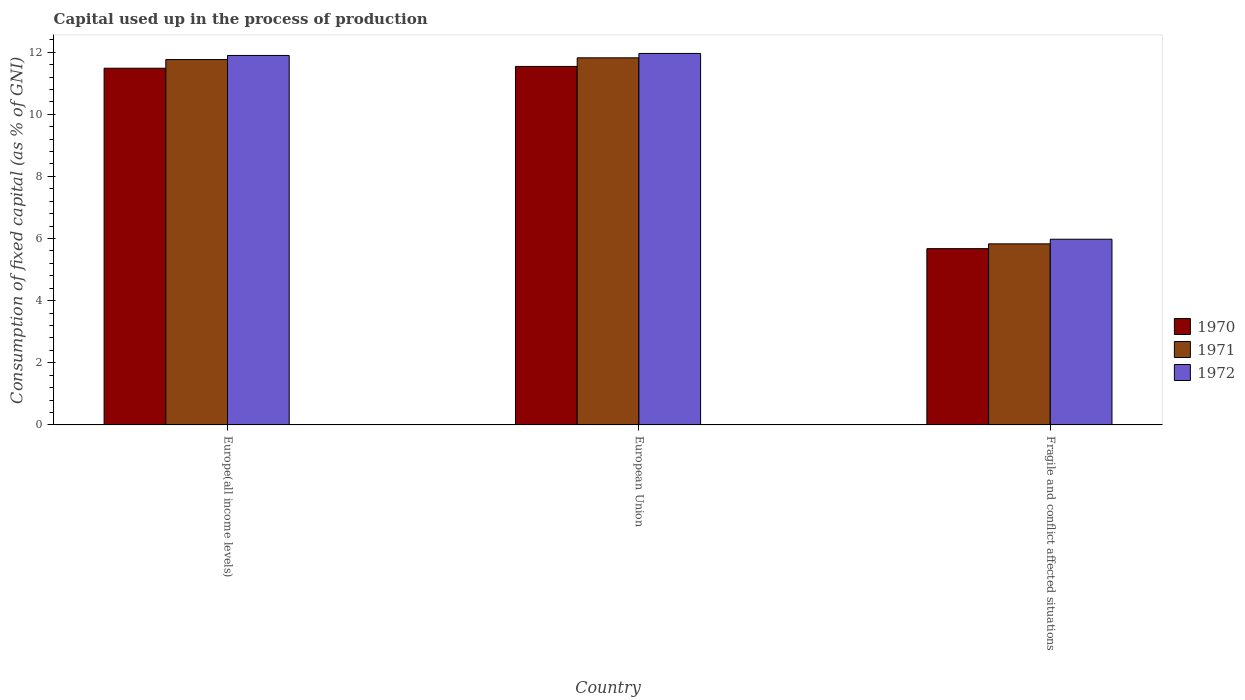Are the number of bars per tick equal to the number of legend labels?
Offer a very short reply. Yes. How many bars are there on the 1st tick from the left?
Ensure brevity in your answer.  3. What is the label of the 3rd group of bars from the left?
Provide a succinct answer. Fragile and conflict affected situations. What is the capital used up in the process of production in 1971 in European Union?
Offer a terse response. 11.82. Across all countries, what is the maximum capital used up in the process of production in 1970?
Give a very brief answer. 11.54. Across all countries, what is the minimum capital used up in the process of production in 1972?
Give a very brief answer. 5.98. In which country was the capital used up in the process of production in 1971 minimum?
Keep it short and to the point. Fragile and conflict affected situations. What is the total capital used up in the process of production in 1970 in the graph?
Offer a terse response. 28.7. What is the difference between the capital used up in the process of production in 1971 in Europe(all income levels) and that in Fragile and conflict affected situations?
Offer a terse response. 5.93. What is the difference between the capital used up in the process of production in 1971 in Fragile and conflict affected situations and the capital used up in the process of production in 1970 in Europe(all income levels)?
Your answer should be very brief. -5.65. What is the average capital used up in the process of production in 1970 per country?
Give a very brief answer. 9.57. What is the difference between the capital used up in the process of production of/in 1972 and capital used up in the process of production of/in 1971 in European Union?
Make the answer very short. 0.14. In how many countries, is the capital used up in the process of production in 1972 greater than 10.8 %?
Ensure brevity in your answer.  2. What is the ratio of the capital used up in the process of production in 1970 in Europe(all income levels) to that in European Union?
Give a very brief answer. 0.99. What is the difference between the highest and the second highest capital used up in the process of production in 1970?
Your answer should be very brief. -0.06. What is the difference between the highest and the lowest capital used up in the process of production in 1970?
Offer a very short reply. 5.87. What does the 1st bar from the left in Europe(all income levels) represents?
Offer a terse response. 1970. Are all the bars in the graph horizontal?
Make the answer very short. No. How many countries are there in the graph?
Your response must be concise. 3. What is the difference between two consecutive major ticks on the Y-axis?
Give a very brief answer. 2. Are the values on the major ticks of Y-axis written in scientific E-notation?
Make the answer very short. No. Does the graph contain any zero values?
Give a very brief answer. No. Does the graph contain grids?
Offer a terse response. No. Where does the legend appear in the graph?
Keep it short and to the point. Center right. How many legend labels are there?
Provide a succinct answer. 3. How are the legend labels stacked?
Make the answer very short. Vertical. What is the title of the graph?
Keep it short and to the point. Capital used up in the process of production. What is the label or title of the X-axis?
Your answer should be very brief. Country. What is the label or title of the Y-axis?
Give a very brief answer. Consumption of fixed capital (as % of GNI). What is the Consumption of fixed capital (as % of GNI) of 1970 in Europe(all income levels)?
Provide a succinct answer. 11.48. What is the Consumption of fixed capital (as % of GNI) of 1971 in Europe(all income levels)?
Give a very brief answer. 11.76. What is the Consumption of fixed capital (as % of GNI) of 1972 in Europe(all income levels)?
Keep it short and to the point. 11.89. What is the Consumption of fixed capital (as % of GNI) in 1970 in European Union?
Your response must be concise. 11.54. What is the Consumption of fixed capital (as % of GNI) of 1971 in European Union?
Provide a short and direct response. 11.82. What is the Consumption of fixed capital (as % of GNI) in 1972 in European Union?
Provide a succinct answer. 11.96. What is the Consumption of fixed capital (as % of GNI) of 1970 in Fragile and conflict affected situations?
Provide a short and direct response. 5.67. What is the Consumption of fixed capital (as % of GNI) in 1971 in Fragile and conflict affected situations?
Provide a short and direct response. 5.83. What is the Consumption of fixed capital (as % of GNI) in 1972 in Fragile and conflict affected situations?
Your answer should be very brief. 5.98. Across all countries, what is the maximum Consumption of fixed capital (as % of GNI) in 1970?
Give a very brief answer. 11.54. Across all countries, what is the maximum Consumption of fixed capital (as % of GNI) of 1971?
Offer a very short reply. 11.82. Across all countries, what is the maximum Consumption of fixed capital (as % of GNI) in 1972?
Your response must be concise. 11.96. Across all countries, what is the minimum Consumption of fixed capital (as % of GNI) of 1970?
Offer a very short reply. 5.67. Across all countries, what is the minimum Consumption of fixed capital (as % of GNI) of 1971?
Offer a very short reply. 5.83. Across all countries, what is the minimum Consumption of fixed capital (as % of GNI) of 1972?
Provide a short and direct response. 5.98. What is the total Consumption of fixed capital (as % of GNI) of 1970 in the graph?
Your answer should be very brief. 28.7. What is the total Consumption of fixed capital (as % of GNI) of 1971 in the graph?
Your answer should be compact. 29.41. What is the total Consumption of fixed capital (as % of GNI) in 1972 in the graph?
Offer a terse response. 29.83. What is the difference between the Consumption of fixed capital (as % of GNI) of 1970 in Europe(all income levels) and that in European Union?
Offer a terse response. -0.06. What is the difference between the Consumption of fixed capital (as % of GNI) in 1971 in Europe(all income levels) and that in European Union?
Offer a terse response. -0.06. What is the difference between the Consumption of fixed capital (as % of GNI) of 1972 in Europe(all income levels) and that in European Union?
Your answer should be very brief. -0.06. What is the difference between the Consumption of fixed capital (as % of GNI) of 1970 in Europe(all income levels) and that in Fragile and conflict affected situations?
Offer a terse response. 5.81. What is the difference between the Consumption of fixed capital (as % of GNI) in 1971 in Europe(all income levels) and that in Fragile and conflict affected situations?
Your response must be concise. 5.93. What is the difference between the Consumption of fixed capital (as % of GNI) in 1972 in Europe(all income levels) and that in Fragile and conflict affected situations?
Your response must be concise. 5.92. What is the difference between the Consumption of fixed capital (as % of GNI) of 1970 in European Union and that in Fragile and conflict affected situations?
Keep it short and to the point. 5.87. What is the difference between the Consumption of fixed capital (as % of GNI) in 1971 in European Union and that in Fragile and conflict affected situations?
Your answer should be very brief. 5.99. What is the difference between the Consumption of fixed capital (as % of GNI) in 1972 in European Union and that in Fragile and conflict affected situations?
Offer a very short reply. 5.98. What is the difference between the Consumption of fixed capital (as % of GNI) in 1970 in Europe(all income levels) and the Consumption of fixed capital (as % of GNI) in 1971 in European Union?
Offer a very short reply. -0.33. What is the difference between the Consumption of fixed capital (as % of GNI) of 1970 in Europe(all income levels) and the Consumption of fixed capital (as % of GNI) of 1972 in European Union?
Your answer should be very brief. -0.48. What is the difference between the Consumption of fixed capital (as % of GNI) of 1971 in Europe(all income levels) and the Consumption of fixed capital (as % of GNI) of 1972 in European Union?
Your answer should be very brief. -0.2. What is the difference between the Consumption of fixed capital (as % of GNI) in 1970 in Europe(all income levels) and the Consumption of fixed capital (as % of GNI) in 1971 in Fragile and conflict affected situations?
Your answer should be compact. 5.65. What is the difference between the Consumption of fixed capital (as % of GNI) in 1970 in Europe(all income levels) and the Consumption of fixed capital (as % of GNI) in 1972 in Fragile and conflict affected situations?
Give a very brief answer. 5.5. What is the difference between the Consumption of fixed capital (as % of GNI) of 1971 in Europe(all income levels) and the Consumption of fixed capital (as % of GNI) of 1972 in Fragile and conflict affected situations?
Your answer should be compact. 5.78. What is the difference between the Consumption of fixed capital (as % of GNI) of 1970 in European Union and the Consumption of fixed capital (as % of GNI) of 1971 in Fragile and conflict affected situations?
Your answer should be compact. 5.71. What is the difference between the Consumption of fixed capital (as % of GNI) of 1970 in European Union and the Consumption of fixed capital (as % of GNI) of 1972 in Fragile and conflict affected situations?
Ensure brevity in your answer.  5.56. What is the difference between the Consumption of fixed capital (as % of GNI) of 1971 in European Union and the Consumption of fixed capital (as % of GNI) of 1972 in Fragile and conflict affected situations?
Offer a terse response. 5.84. What is the average Consumption of fixed capital (as % of GNI) of 1970 per country?
Your answer should be very brief. 9.57. What is the average Consumption of fixed capital (as % of GNI) of 1971 per country?
Your answer should be compact. 9.8. What is the average Consumption of fixed capital (as % of GNI) of 1972 per country?
Provide a short and direct response. 9.94. What is the difference between the Consumption of fixed capital (as % of GNI) in 1970 and Consumption of fixed capital (as % of GNI) in 1971 in Europe(all income levels)?
Keep it short and to the point. -0.28. What is the difference between the Consumption of fixed capital (as % of GNI) of 1970 and Consumption of fixed capital (as % of GNI) of 1972 in Europe(all income levels)?
Your answer should be very brief. -0.41. What is the difference between the Consumption of fixed capital (as % of GNI) in 1971 and Consumption of fixed capital (as % of GNI) in 1972 in Europe(all income levels)?
Give a very brief answer. -0.13. What is the difference between the Consumption of fixed capital (as % of GNI) in 1970 and Consumption of fixed capital (as % of GNI) in 1971 in European Union?
Give a very brief answer. -0.28. What is the difference between the Consumption of fixed capital (as % of GNI) in 1970 and Consumption of fixed capital (as % of GNI) in 1972 in European Union?
Keep it short and to the point. -0.42. What is the difference between the Consumption of fixed capital (as % of GNI) of 1971 and Consumption of fixed capital (as % of GNI) of 1972 in European Union?
Ensure brevity in your answer.  -0.14. What is the difference between the Consumption of fixed capital (as % of GNI) of 1970 and Consumption of fixed capital (as % of GNI) of 1971 in Fragile and conflict affected situations?
Give a very brief answer. -0.15. What is the difference between the Consumption of fixed capital (as % of GNI) in 1970 and Consumption of fixed capital (as % of GNI) in 1972 in Fragile and conflict affected situations?
Your answer should be compact. -0.3. What is the difference between the Consumption of fixed capital (as % of GNI) in 1971 and Consumption of fixed capital (as % of GNI) in 1972 in Fragile and conflict affected situations?
Your answer should be very brief. -0.15. What is the ratio of the Consumption of fixed capital (as % of GNI) of 1970 in Europe(all income levels) to that in European Union?
Make the answer very short. 0.99. What is the ratio of the Consumption of fixed capital (as % of GNI) of 1971 in Europe(all income levels) to that in European Union?
Keep it short and to the point. 1. What is the ratio of the Consumption of fixed capital (as % of GNI) in 1970 in Europe(all income levels) to that in Fragile and conflict affected situations?
Your answer should be compact. 2.02. What is the ratio of the Consumption of fixed capital (as % of GNI) in 1971 in Europe(all income levels) to that in Fragile and conflict affected situations?
Your answer should be very brief. 2.02. What is the ratio of the Consumption of fixed capital (as % of GNI) in 1972 in Europe(all income levels) to that in Fragile and conflict affected situations?
Give a very brief answer. 1.99. What is the ratio of the Consumption of fixed capital (as % of GNI) in 1970 in European Union to that in Fragile and conflict affected situations?
Make the answer very short. 2.03. What is the ratio of the Consumption of fixed capital (as % of GNI) in 1971 in European Union to that in Fragile and conflict affected situations?
Ensure brevity in your answer.  2.03. What is the ratio of the Consumption of fixed capital (as % of GNI) of 1972 in European Union to that in Fragile and conflict affected situations?
Your answer should be very brief. 2. What is the difference between the highest and the second highest Consumption of fixed capital (as % of GNI) of 1970?
Offer a very short reply. 0.06. What is the difference between the highest and the second highest Consumption of fixed capital (as % of GNI) of 1971?
Your answer should be very brief. 0.06. What is the difference between the highest and the second highest Consumption of fixed capital (as % of GNI) in 1972?
Provide a succinct answer. 0.06. What is the difference between the highest and the lowest Consumption of fixed capital (as % of GNI) of 1970?
Provide a succinct answer. 5.87. What is the difference between the highest and the lowest Consumption of fixed capital (as % of GNI) in 1971?
Your answer should be compact. 5.99. What is the difference between the highest and the lowest Consumption of fixed capital (as % of GNI) of 1972?
Your response must be concise. 5.98. 